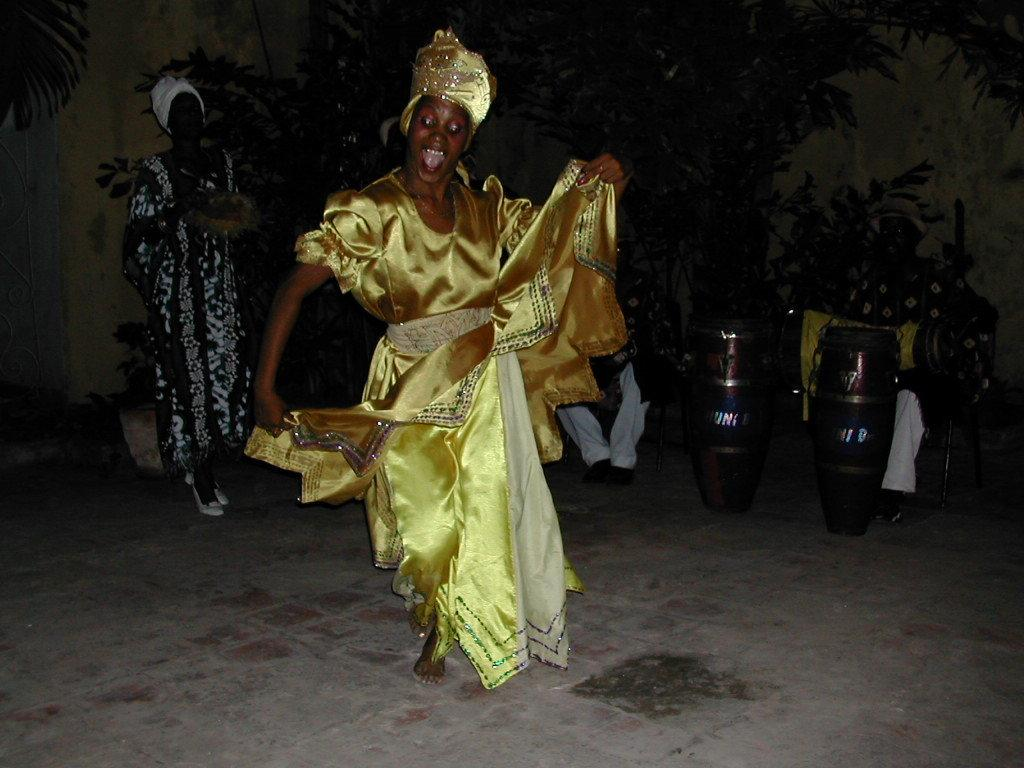What is the person in the image wearing? The person in the image is wearing yellow costumes. What is the person doing in the image? The person is dancing on the floor. What can be seen in the background of the image? There are people, musical instruments, plants, and a wall in the background of the image. What type of silk is being used by the doctor in the image? There is no doctor or silk present in the image. How many bananas are being held by the person in the image? There are no bananas present in the image; the person is wearing yellow costumes and dancing on the floor. 